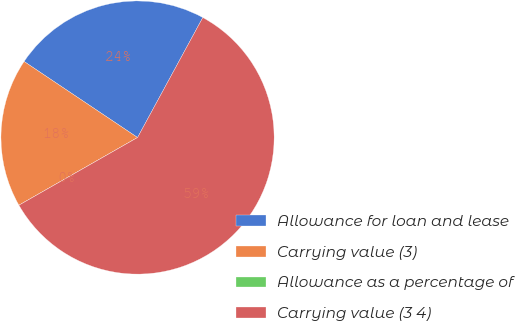<chart> <loc_0><loc_0><loc_500><loc_500><pie_chart><fcel>Allowance for loan and lease<fcel>Carrying value (3)<fcel>Allowance as a percentage of<fcel>Carrying value (3 4)<nl><fcel>23.53%<fcel>17.65%<fcel>0.0%<fcel>58.82%<nl></chart> 